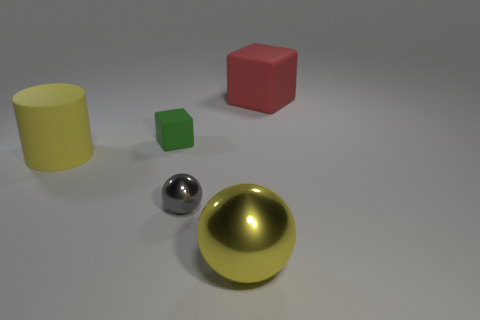There is a rubber thing that is right of the large yellow cylinder and to the left of the yellow sphere; what is its shape?
Your answer should be very brief. Cube. Are there any green things?
Your response must be concise. Yes. There is a green object that is the same shape as the big red matte thing; what material is it?
Give a very brief answer. Rubber. The large matte thing to the left of the big object in front of the big rubber thing that is to the left of the red object is what shape?
Your response must be concise. Cylinder. There is a cylinder that is the same color as the big sphere; what is it made of?
Keep it short and to the point. Rubber. How many other small green objects are the same shape as the small matte object?
Ensure brevity in your answer.  0. Does the rubber block that is in front of the large block have the same color as the small thing that is right of the green thing?
Ensure brevity in your answer.  No. There is a ball that is the same size as the green matte object; what is its material?
Your answer should be compact. Metal. Are there any gray objects of the same size as the yellow sphere?
Make the answer very short. No. Are there fewer big yellow metallic objects that are on the left side of the green object than big things?
Ensure brevity in your answer.  Yes. 